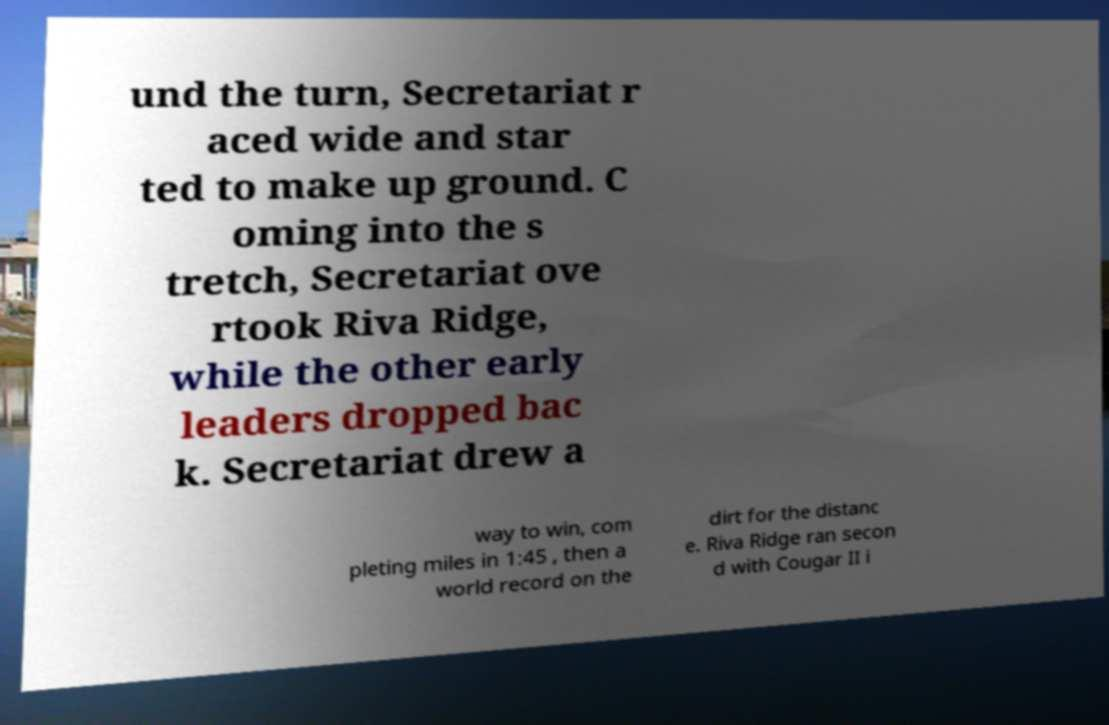What messages or text are displayed in this image? I need them in a readable, typed format. und the turn, Secretariat r aced wide and star ted to make up ground. C oming into the s tretch, Secretariat ove rtook Riva Ridge, while the other early leaders dropped bac k. Secretariat drew a way to win, com pleting miles in 1:45 , then a world record on the dirt for the distanc e. Riva Ridge ran secon d with Cougar II i 